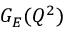<formula> <loc_0><loc_0><loc_500><loc_500>G _ { E } ( Q ^ { 2 } )</formula> 